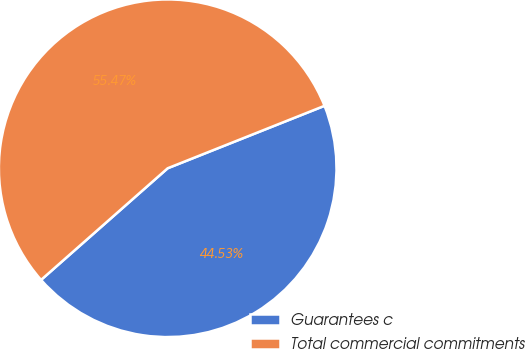Convert chart to OTSL. <chart><loc_0><loc_0><loc_500><loc_500><pie_chart><fcel>Guarantees c<fcel>Total commercial commitments<nl><fcel>44.53%<fcel>55.47%<nl></chart> 